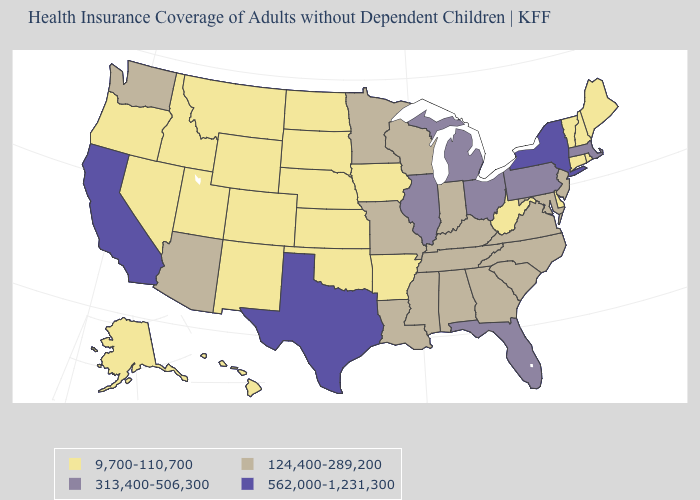Name the states that have a value in the range 124,400-289,200?
Answer briefly. Alabama, Arizona, Georgia, Indiana, Kentucky, Louisiana, Maryland, Minnesota, Mississippi, Missouri, New Jersey, North Carolina, South Carolina, Tennessee, Virginia, Washington, Wisconsin. Which states hav the highest value in the West?
Answer briefly. California. Is the legend a continuous bar?
Short answer required. No. Among the states that border Arizona , which have the highest value?
Answer briefly. California. What is the lowest value in the MidWest?
Be succinct. 9,700-110,700. What is the highest value in states that border Florida?
Quick response, please. 124,400-289,200. Does the first symbol in the legend represent the smallest category?
Concise answer only. Yes. Name the states that have a value in the range 9,700-110,700?
Write a very short answer. Alaska, Arkansas, Colorado, Connecticut, Delaware, Hawaii, Idaho, Iowa, Kansas, Maine, Montana, Nebraska, Nevada, New Hampshire, New Mexico, North Dakota, Oklahoma, Oregon, Rhode Island, South Dakota, Utah, Vermont, West Virginia, Wyoming. Does Maine have the lowest value in the USA?
Quick response, please. Yes. Which states have the lowest value in the West?
Answer briefly. Alaska, Colorado, Hawaii, Idaho, Montana, Nevada, New Mexico, Oregon, Utah, Wyoming. Name the states that have a value in the range 124,400-289,200?
Answer briefly. Alabama, Arizona, Georgia, Indiana, Kentucky, Louisiana, Maryland, Minnesota, Mississippi, Missouri, New Jersey, North Carolina, South Carolina, Tennessee, Virginia, Washington, Wisconsin. Does Washington have the same value as Rhode Island?
Answer briefly. No. Does Idaho have the same value as Vermont?
Write a very short answer. Yes. Name the states that have a value in the range 124,400-289,200?
Quick response, please. Alabama, Arizona, Georgia, Indiana, Kentucky, Louisiana, Maryland, Minnesota, Mississippi, Missouri, New Jersey, North Carolina, South Carolina, Tennessee, Virginia, Washington, Wisconsin. What is the value of Wisconsin?
Give a very brief answer. 124,400-289,200. 